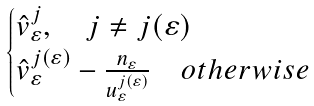Convert formula to latex. <formula><loc_0><loc_0><loc_500><loc_500>\begin{cases} \hat { v } _ { \varepsilon } ^ { j } , \quad j \neq j ( \varepsilon ) \\ \hat { v } _ { \varepsilon } ^ { j ( \varepsilon ) } - \frac { n _ { \varepsilon } } { u _ { \varepsilon } ^ { j ( \varepsilon ) } } \quad o t h e r w i s e \end{cases}</formula> 